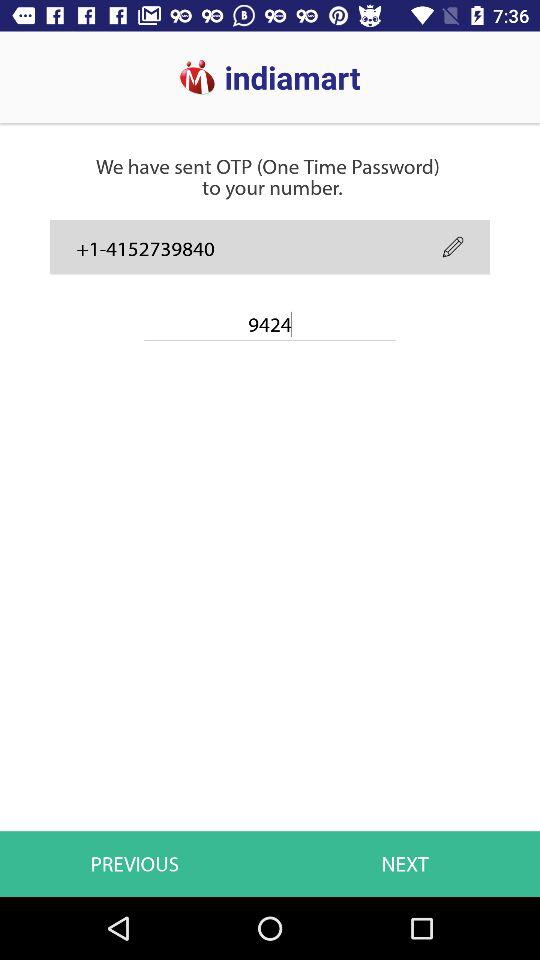How many digits are there in the phone number?
Answer the question using a single word or phrase. 10 